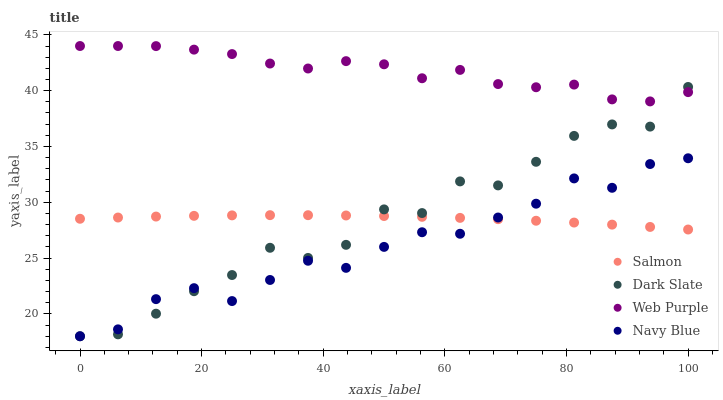Does Navy Blue have the minimum area under the curve?
Answer yes or no. Yes. Does Web Purple have the maximum area under the curve?
Answer yes or no. Yes. Does Salmon have the minimum area under the curve?
Answer yes or no. No. Does Salmon have the maximum area under the curve?
Answer yes or no. No. Is Salmon the smoothest?
Answer yes or no. Yes. Is Dark Slate the roughest?
Answer yes or no. Yes. Is Web Purple the smoothest?
Answer yes or no. No. Is Web Purple the roughest?
Answer yes or no. No. Does Dark Slate have the lowest value?
Answer yes or no. Yes. Does Salmon have the lowest value?
Answer yes or no. No. Does Web Purple have the highest value?
Answer yes or no. Yes. Does Salmon have the highest value?
Answer yes or no. No. Is Salmon less than Web Purple?
Answer yes or no. Yes. Is Web Purple greater than Navy Blue?
Answer yes or no. Yes. Does Dark Slate intersect Salmon?
Answer yes or no. Yes. Is Dark Slate less than Salmon?
Answer yes or no. No. Is Dark Slate greater than Salmon?
Answer yes or no. No. Does Salmon intersect Web Purple?
Answer yes or no. No. 